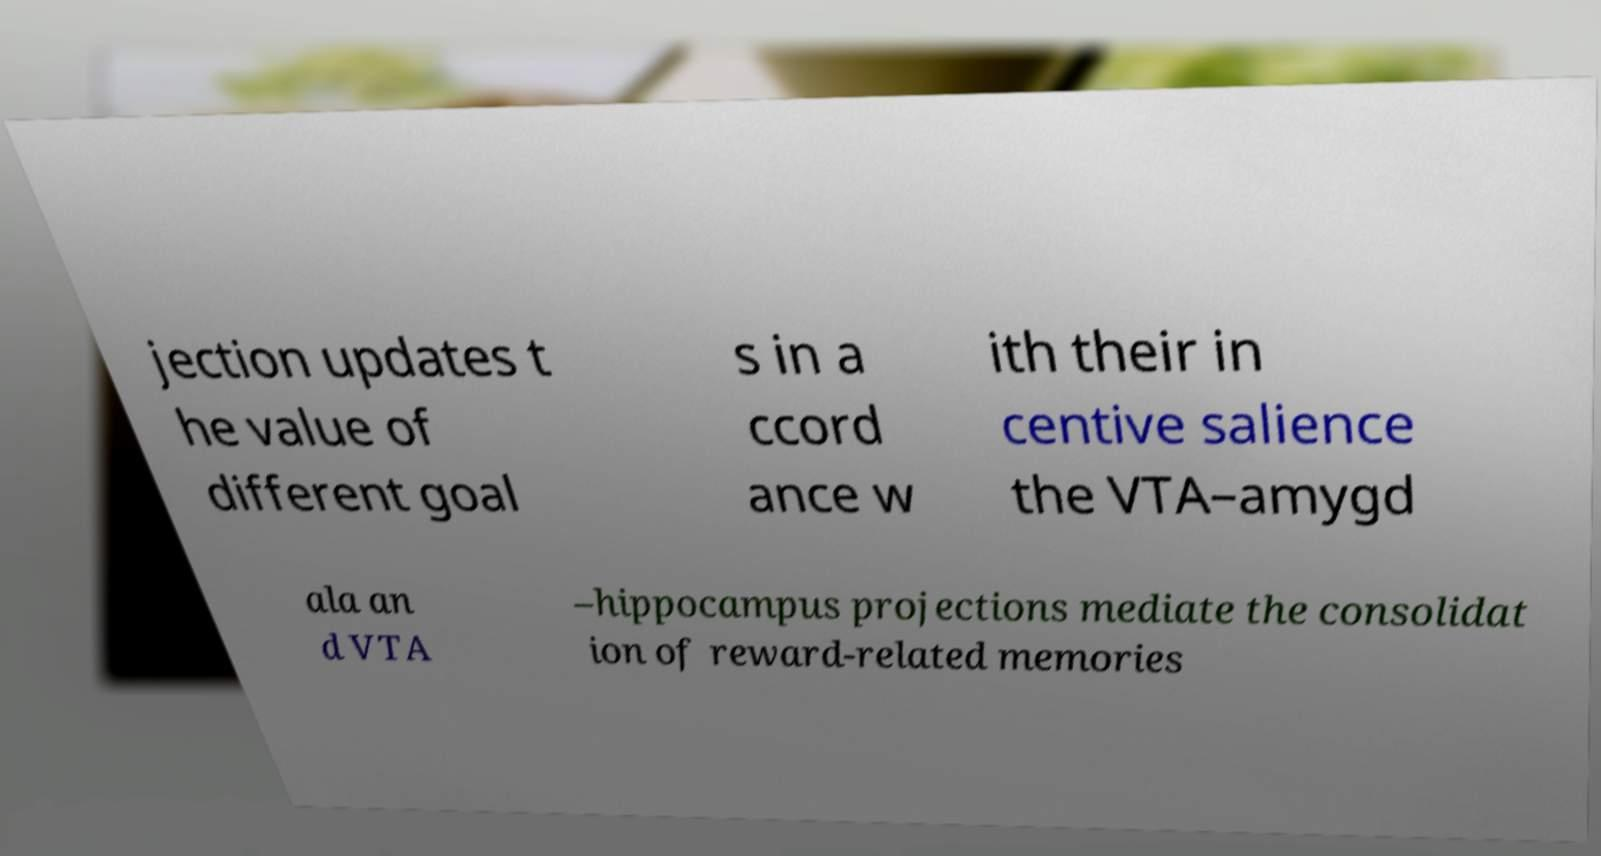There's text embedded in this image that I need extracted. Can you transcribe it verbatim? jection updates t he value of different goal s in a ccord ance w ith their in centive salience the VTA–amygd ala an d VTA –hippocampus projections mediate the consolidat ion of reward-related memories 